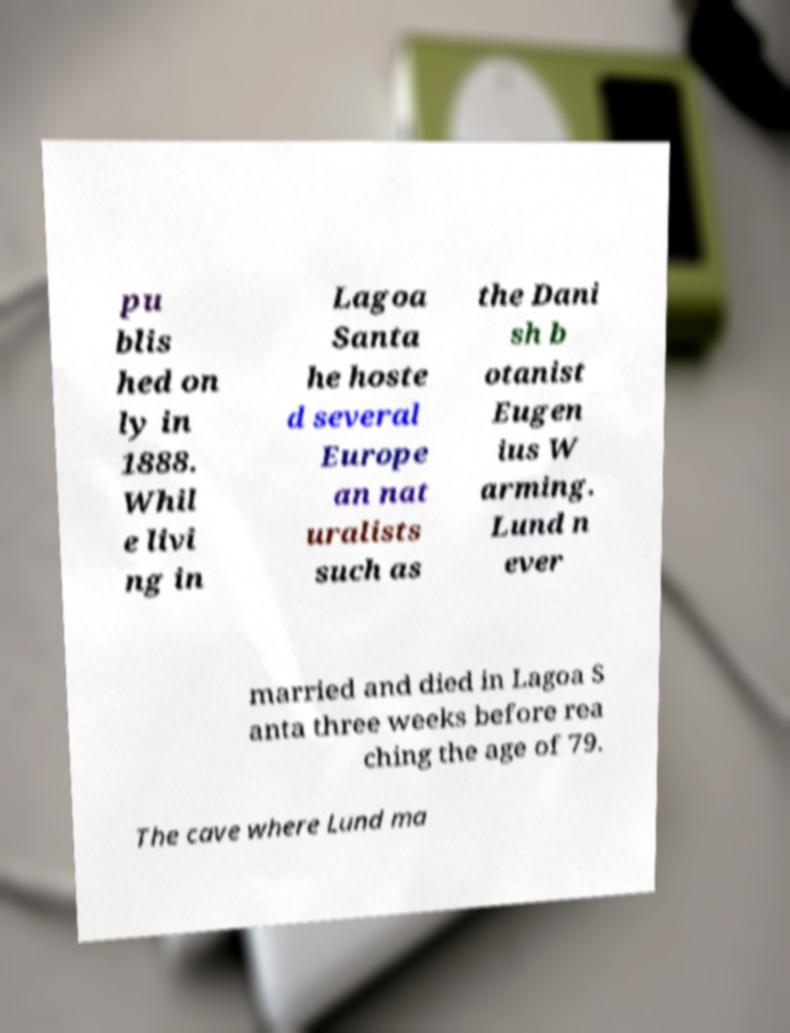Can you read and provide the text displayed in the image?This photo seems to have some interesting text. Can you extract and type it out for me? pu blis hed on ly in 1888. Whil e livi ng in Lagoa Santa he hoste d several Europe an nat uralists such as the Dani sh b otanist Eugen ius W arming. Lund n ever married and died in Lagoa S anta three weeks before rea ching the age of 79. The cave where Lund ma 